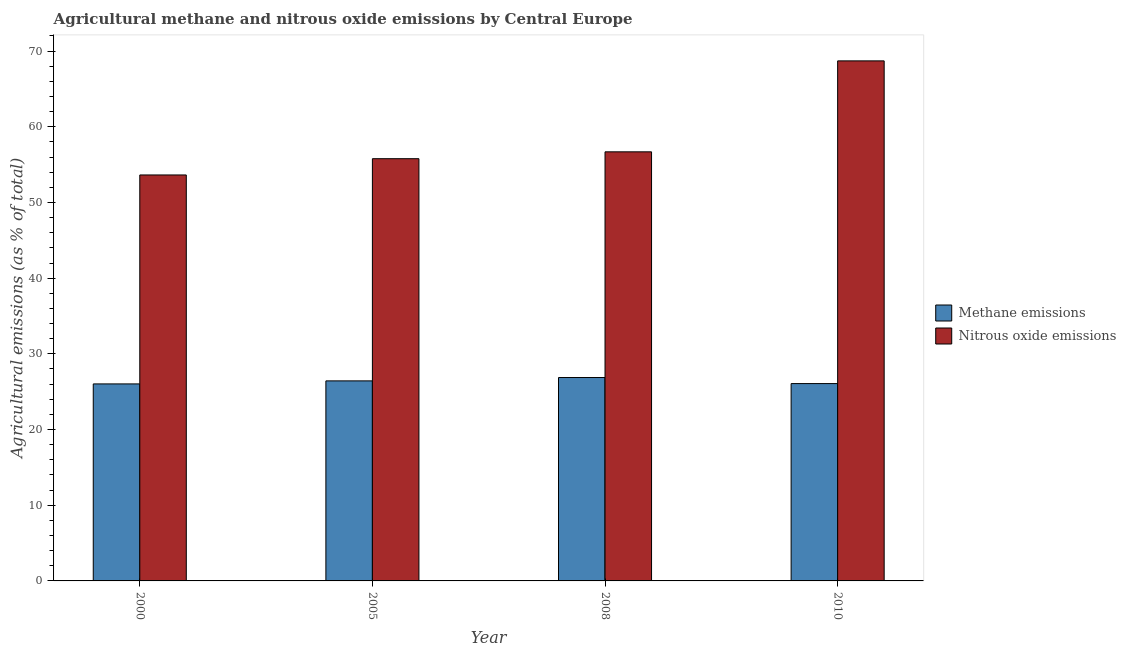How many different coloured bars are there?
Make the answer very short. 2. Are the number of bars on each tick of the X-axis equal?
Make the answer very short. Yes. How many bars are there on the 4th tick from the left?
Keep it short and to the point. 2. In how many cases, is the number of bars for a given year not equal to the number of legend labels?
Your response must be concise. 0. What is the amount of methane emissions in 2005?
Provide a short and direct response. 26.43. Across all years, what is the maximum amount of nitrous oxide emissions?
Ensure brevity in your answer.  68.71. Across all years, what is the minimum amount of methane emissions?
Make the answer very short. 26.03. In which year was the amount of methane emissions maximum?
Ensure brevity in your answer.  2008. What is the total amount of nitrous oxide emissions in the graph?
Ensure brevity in your answer.  234.83. What is the difference between the amount of nitrous oxide emissions in 2000 and that in 2010?
Your answer should be compact. -15.07. What is the difference between the amount of nitrous oxide emissions in 2005 and the amount of methane emissions in 2010?
Keep it short and to the point. -12.92. What is the average amount of methane emissions per year?
Give a very brief answer. 26.35. In how many years, is the amount of methane emissions greater than 2 %?
Ensure brevity in your answer.  4. What is the ratio of the amount of methane emissions in 2000 to that in 2008?
Your answer should be compact. 0.97. Is the amount of methane emissions in 2005 less than that in 2008?
Offer a terse response. Yes. Is the difference between the amount of nitrous oxide emissions in 2000 and 2008 greater than the difference between the amount of methane emissions in 2000 and 2008?
Your response must be concise. No. What is the difference between the highest and the second highest amount of nitrous oxide emissions?
Make the answer very short. 12.02. What is the difference between the highest and the lowest amount of nitrous oxide emissions?
Keep it short and to the point. 15.07. In how many years, is the amount of nitrous oxide emissions greater than the average amount of nitrous oxide emissions taken over all years?
Give a very brief answer. 1. Is the sum of the amount of nitrous oxide emissions in 2000 and 2005 greater than the maximum amount of methane emissions across all years?
Provide a succinct answer. Yes. What does the 2nd bar from the left in 2008 represents?
Provide a succinct answer. Nitrous oxide emissions. What does the 2nd bar from the right in 2000 represents?
Your response must be concise. Methane emissions. How many bars are there?
Your answer should be compact. 8. Are all the bars in the graph horizontal?
Provide a short and direct response. No. How many years are there in the graph?
Your response must be concise. 4. What is the difference between two consecutive major ticks on the Y-axis?
Ensure brevity in your answer.  10. Are the values on the major ticks of Y-axis written in scientific E-notation?
Your answer should be very brief. No. How many legend labels are there?
Offer a very short reply. 2. How are the legend labels stacked?
Keep it short and to the point. Vertical. What is the title of the graph?
Provide a short and direct response. Agricultural methane and nitrous oxide emissions by Central Europe. Does "Attending school" appear as one of the legend labels in the graph?
Provide a succinct answer. No. What is the label or title of the X-axis?
Your answer should be compact. Year. What is the label or title of the Y-axis?
Keep it short and to the point. Agricultural emissions (as % of total). What is the Agricultural emissions (as % of total) in Methane emissions in 2000?
Ensure brevity in your answer.  26.03. What is the Agricultural emissions (as % of total) of Nitrous oxide emissions in 2000?
Your answer should be very brief. 53.64. What is the Agricultural emissions (as % of total) of Methane emissions in 2005?
Make the answer very short. 26.43. What is the Agricultural emissions (as % of total) of Nitrous oxide emissions in 2005?
Your answer should be compact. 55.79. What is the Agricultural emissions (as % of total) of Methane emissions in 2008?
Your answer should be compact. 26.87. What is the Agricultural emissions (as % of total) of Nitrous oxide emissions in 2008?
Provide a short and direct response. 56.69. What is the Agricultural emissions (as % of total) of Methane emissions in 2010?
Provide a short and direct response. 26.07. What is the Agricultural emissions (as % of total) in Nitrous oxide emissions in 2010?
Give a very brief answer. 68.71. Across all years, what is the maximum Agricultural emissions (as % of total) of Methane emissions?
Give a very brief answer. 26.87. Across all years, what is the maximum Agricultural emissions (as % of total) in Nitrous oxide emissions?
Offer a very short reply. 68.71. Across all years, what is the minimum Agricultural emissions (as % of total) in Methane emissions?
Your answer should be compact. 26.03. Across all years, what is the minimum Agricultural emissions (as % of total) of Nitrous oxide emissions?
Ensure brevity in your answer.  53.64. What is the total Agricultural emissions (as % of total) of Methane emissions in the graph?
Ensure brevity in your answer.  105.41. What is the total Agricultural emissions (as % of total) of Nitrous oxide emissions in the graph?
Provide a short and direct response. 234.83. What is the difference between the Agricultural emissions (as % of total) of Methane emissions in 2000 and that in 2005?
Give a very brief answer. -0.4. What is the difference between the Agricultural emissions (as % of total) in Nitrous oxide emissions in 2000 and that in 2005?
Your answer should be very brief. -2.15. What is the difference between the Agricultural emissions (as % of total) of Methane emissions in 2000 and that in 2008?
Your answer should be very brief. -0.84. What is the difference between the Agricultural emissions (as % of total) of Nitrous oxide emissions in 2000 and that in 2008?
Provide a succinct answer. -3.06. What is the difference between the Agricultural emissions (as % of total) in Methane emissions in 2000 and that in 2010?
Offer a terse response. -0.04. What is the difference between the Agricultural emissions (as % of total) of Nitrous oxide emissions in 2000 and that in 2010?
Ensure brevity in your answer.  -15.07. What is the difference between the Agricultural emissions (as % of total) in Methane emissions in 2005 and that in 2008?
Your answer should be compact. -0.44. What is the difference between the Agricultural emissions (as % of total) in Nitrous oxide emissions in 2005 and that in 2008?
Your answer should be compact. -0.91. What is the difference between the Agricultural emissions (as % of total) in Methane emissions in 2005 and that in 2010?
Offer a terse response. 0.36. What is the difference between the Agricultural emissions (as % of total) in Nitrous oxide emissions in 2005 and that in 2010?
Make the answer very short. -12.92. What is the difference between the Agricultural emissions (as % of total) of Methane emissions in 2008 and that in 2010?
Your response must be concise. 0.8. What is the difference between the Agricultural emissions (as % of total) in Nitrous oxide emissions in 2008 and that in 2010?
Make the answer very short. -12.02. What is the difference between the Agricultural emissions (as % of total) of Methane emissions in 2000 and the Agricultural emissions (as % of total) of Nitrous oxide emissions in 2005?
Ensure brevity in your answer.  -29.76. What is the difference between the Agricultural emissions (as % of total) of Methane emissions in 2000 and the Agricultural emissions (as % of total) of Nitrous oxide emissions in 2008?
Offer a terse response. -30.66. What is the difference between the Agricultural emissions (as % of total) of Methane emissions in 2000 and the Agricultural emissions (as % of total) of Nitrous oxide emissions in 2010?
Keep it short and to the point. -42.68. What is the difference between the Agricultural emissions (as % of total) in Methane emissions in 2005 and the Agricultural emissions (as % of total) in Nitrous oxide emissions in 2008?
Your answer should be very brief. -30.26. What is the difference between the Agricultural emissions (as % of total) in Methane emissions in 2005 and the Agricultural emissions (as % of total) in Nitrous oxide emissions in 2010?
Your answer should be very brief. -42.28. What is the difference between the Agricultural emissions (as % of total) of Methane emissions in 2008 and the Agricultural emissions (as % of total) of Nitrous oxide emissions in 2010?
Provide a succinct answer. -41.84. What is the average Agricultural emissions (as % of total) in Methane emissions per year?
Keep it short and to the point. 26.35. What is the average Agricultural emissions (as % of total) of Nitrous oxide emissions per year?
Your answer should be compact. 58.71. In the year 2000, what is the difference between the Agricultural emissions (as % of total) of Methane emissions and Agricultural emissions (as % of total) of Nitrous oxide emissions?
Ensure brevity in your answer.  -27.61. In the year 2005, what is the difference between the Agricultural emissions (as % of total) in Methane emissions and Agricultural emissions (as % of total) in Nitrous oxide emissions?
Offer a terse response. -29.36. In the year 2008, what is the difference between the Agricultural emissions (as % of total) of Methane emissions and Agricultural emissions (as % of total) of Nitrous oxide emissions?
Provide a succinct answer. -29.82. In the year 2010, what is the difference between the Agricultural emissions (as % of total) in Methane emissions and Agricultural emissions (as % of total) in Nitrous oxide emissions?
Keep it short and to the point. -42.64. What is the ratio of the Agricultural emissions (as % of total) in Methane emissions in 2000 to that in 2005?
Make the answer very short. 0.98. What is the ratio of the Agricultural emissions (as % of total) of Nitrous oxide emissions in 2000 to that in 2005?
Keep it short and to the point. 0.96. What is the ratio of the Agricultural emissions (as % of total) of Methane emissions in 2000 to that in 2008?
Provide a short and direct response. 0.97. What is the ratio of the Agricultural emissions (as % of total) in Nitrous oxide emissions in 2000 to that in 2008?
Make the answer very short. 0.95. What is the ratio of the Agricultural emissions (as % of total) of Methane emissions in 2000 to that in 2010?
Provide a succinct answer. 1. What is the ratio of the Agricultural emissions (as % of total) in Nitrous oxide emissions in 2000 to that in 2010?
Your response must be concise. 0.78. What is the ratio of the Agricultural emissions (as % of total) in Methane emissions in 2005 to that in 2008?
Provide a short and direct response. 0.98. What is the ratio of the Agricultural emissions (as % of total) in Nitrous oxide emissions in 2005 to that in 2008?
Your response must be concise. 0.98. What is the ratio of the Agricultural emissions (as % of total) of Methane emissions in 2005 to that in 2010?
Provide a short and direct response. 1.01. What is the ratio of the Agricultural emissions (as % of total) of Nitrous oxide emissions in 2005 to that in 2010?
Ensure brevity in your answer.  0.81. What is the ratio of the Agricultural emissions (as % of total) of Methane emissions in 2008 to that in 2010?
Keep it short and to the point. 1.03. What is the ratio of the Agricultural emissions (as % of total) in Nitrous oxide emissions in 2008 to that in 2010?
Your answer should be very brief. 0.83. What is the difference between the highest and the second highest Agricultural emissions (as % of total) in Methane emissions?
Your answer should be very brief. 0.44. What is the difference between the highest and the second highest Agricultural emissions (as % of total) of Nitrous oxide emissions?
Provide a succinct answer. 12.02. What is the difference between the highest and the lowest Agricultural emissions (as % of total) in Methane emissions?
Ensure brevity in your answer.  0.84. What is the difference between the highest and the lowest Agricultural emissions (as % of total) in Nitrous oxide emissions?
Your answer should be compact. 15.07. 